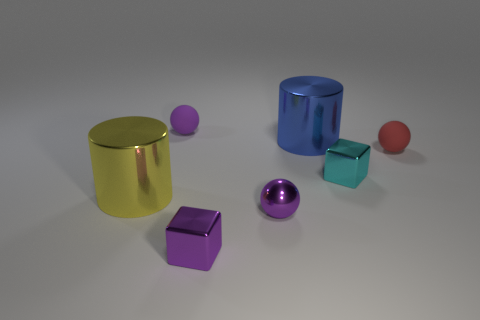Add 1 gray rubber cubes. How many objects exist? 8 Subtract all blocks. How many objects are left? 5 Subtract all green metallic spheres. Subtract all big cylinders. How many objects are left? 5 Add 5 small things. How many small things are left? 10 Add 7 small matte objects. How many small matte objects exist? 9 Subtract 0 brown cubes. How many objects are left? 7 